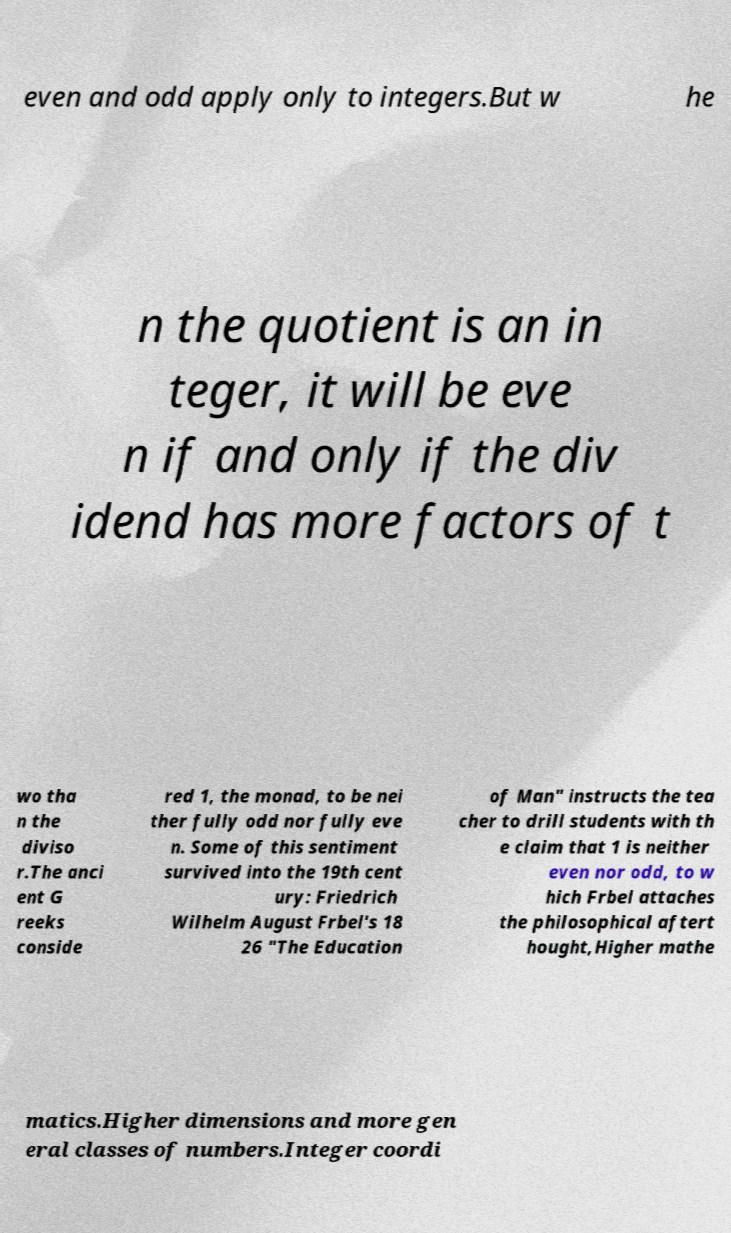I need the written content from this picture converted into text. Can you do that? even and odd apply only to integers.But w he n the quotient is an in teger, it will be eve n if and only if the div idend has more factors of t wo tha n the diviso r.The anci ent G reeks conside red 1, the monad, to be nei ther fully odd nor fully eve n. Some of this sentiment survived into the 19th cent ury: Friedrich Wilhelm August Frbel's 18 26 "The Education of Man" instructs the tea cher to drill students with th e claim that 1 is neither even nor odd, to w hich Frbel attaches the philosophical aftert hought,Higher mathe matics.Higher dimensions and more gen eral classes of numbers.Integer coordi 